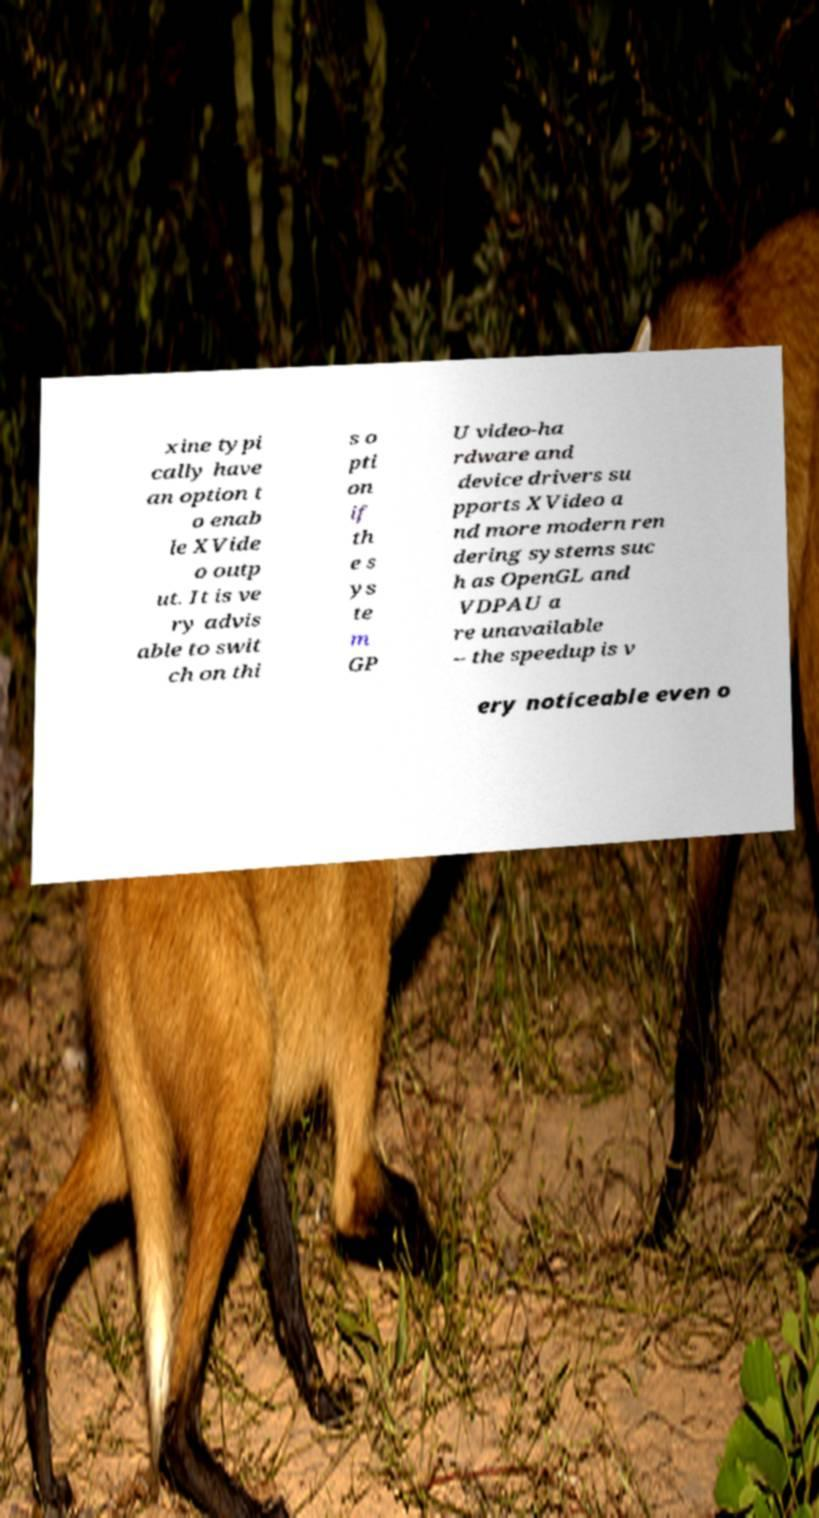There's text embedded in this image that I need extracted. Can you transcribe it verbatim? xine typi cally have an option t o enab le XVide o outp ut. It is ve ry advis able to swit ch on thi s o pti on if th e s ys te m GP U video-ha rdware and device drivers su pports XVideo a nd more modern ren dering systems suc h as OpenGL and VDPAU a re unavailable – the speedup is v ery noticeable even o 